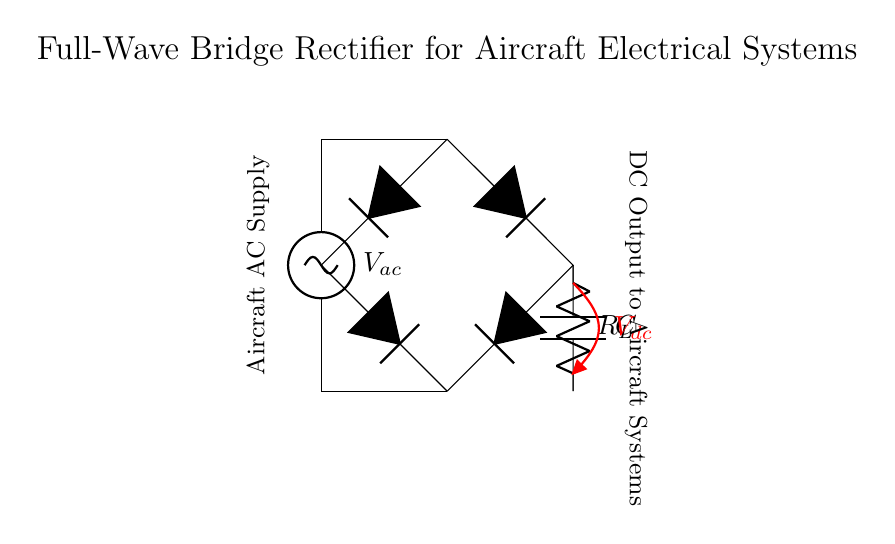What type of rectifier is shown in the circuit? The circuit diagram illustrates a full-wave bridge rectifier, which utilizes four diodes configured in a bridge arrangement to convert alternating current to direct current.
Answer: full-wave bridge rectifier How many diodes are present in the circuit? There are four diodes depicted in the circuit, essential for the bridge rectifier operation, allowing current to flow in both halves of the AC waveform.
Answer: four What is the purpose of the capacitor in this circuit? The capacitor is used for smoothing the output voltage, reducing ripple and providing a more stable direct current for the load.
Answer: smoothing What does the load resistor represent in the circuit? The load resistor represents the component or system that consumes electrical energy, thereby allowing the rectifier to deliver power to the aircraft systems.
Answer: load What is the output voltage labeled in the circuit? The output voltage is denoted as V subscript dc, which represents the direct voltage supplied to the aircraft systems after rectification.
Answer: V subscript dc Why is this type of rectifier preferred in aircraft electrical systems? The full-wave bridge rectifier is preferred in aircraft systems because it ensures efficient power conversion by utilizing both halves of the AC signal, resulting in higher output and improved reliability compared to half-wave rectifiers.
Answer: efficiency and reliability What is the AC supply referred to in the diagram? The AC supply in the diagram is labeled as V subscript ac, representing the alternating current source that powers the circuit and is converted to direct current by the rectifier.
Answer: V subscript ac 